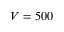<formula> <loc_0><loc_0><loc_500><loc_500>V = 5 0 0</formula> 